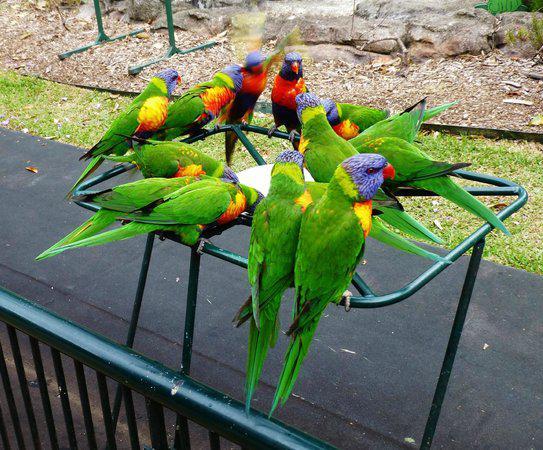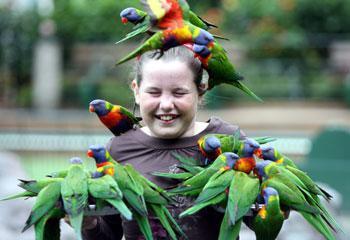The first image is the image on the left, the second image is the image on the right. For the images shown, is this caption "Birds are perched on a person in the image on the left." true? Answer yes or no. No. 